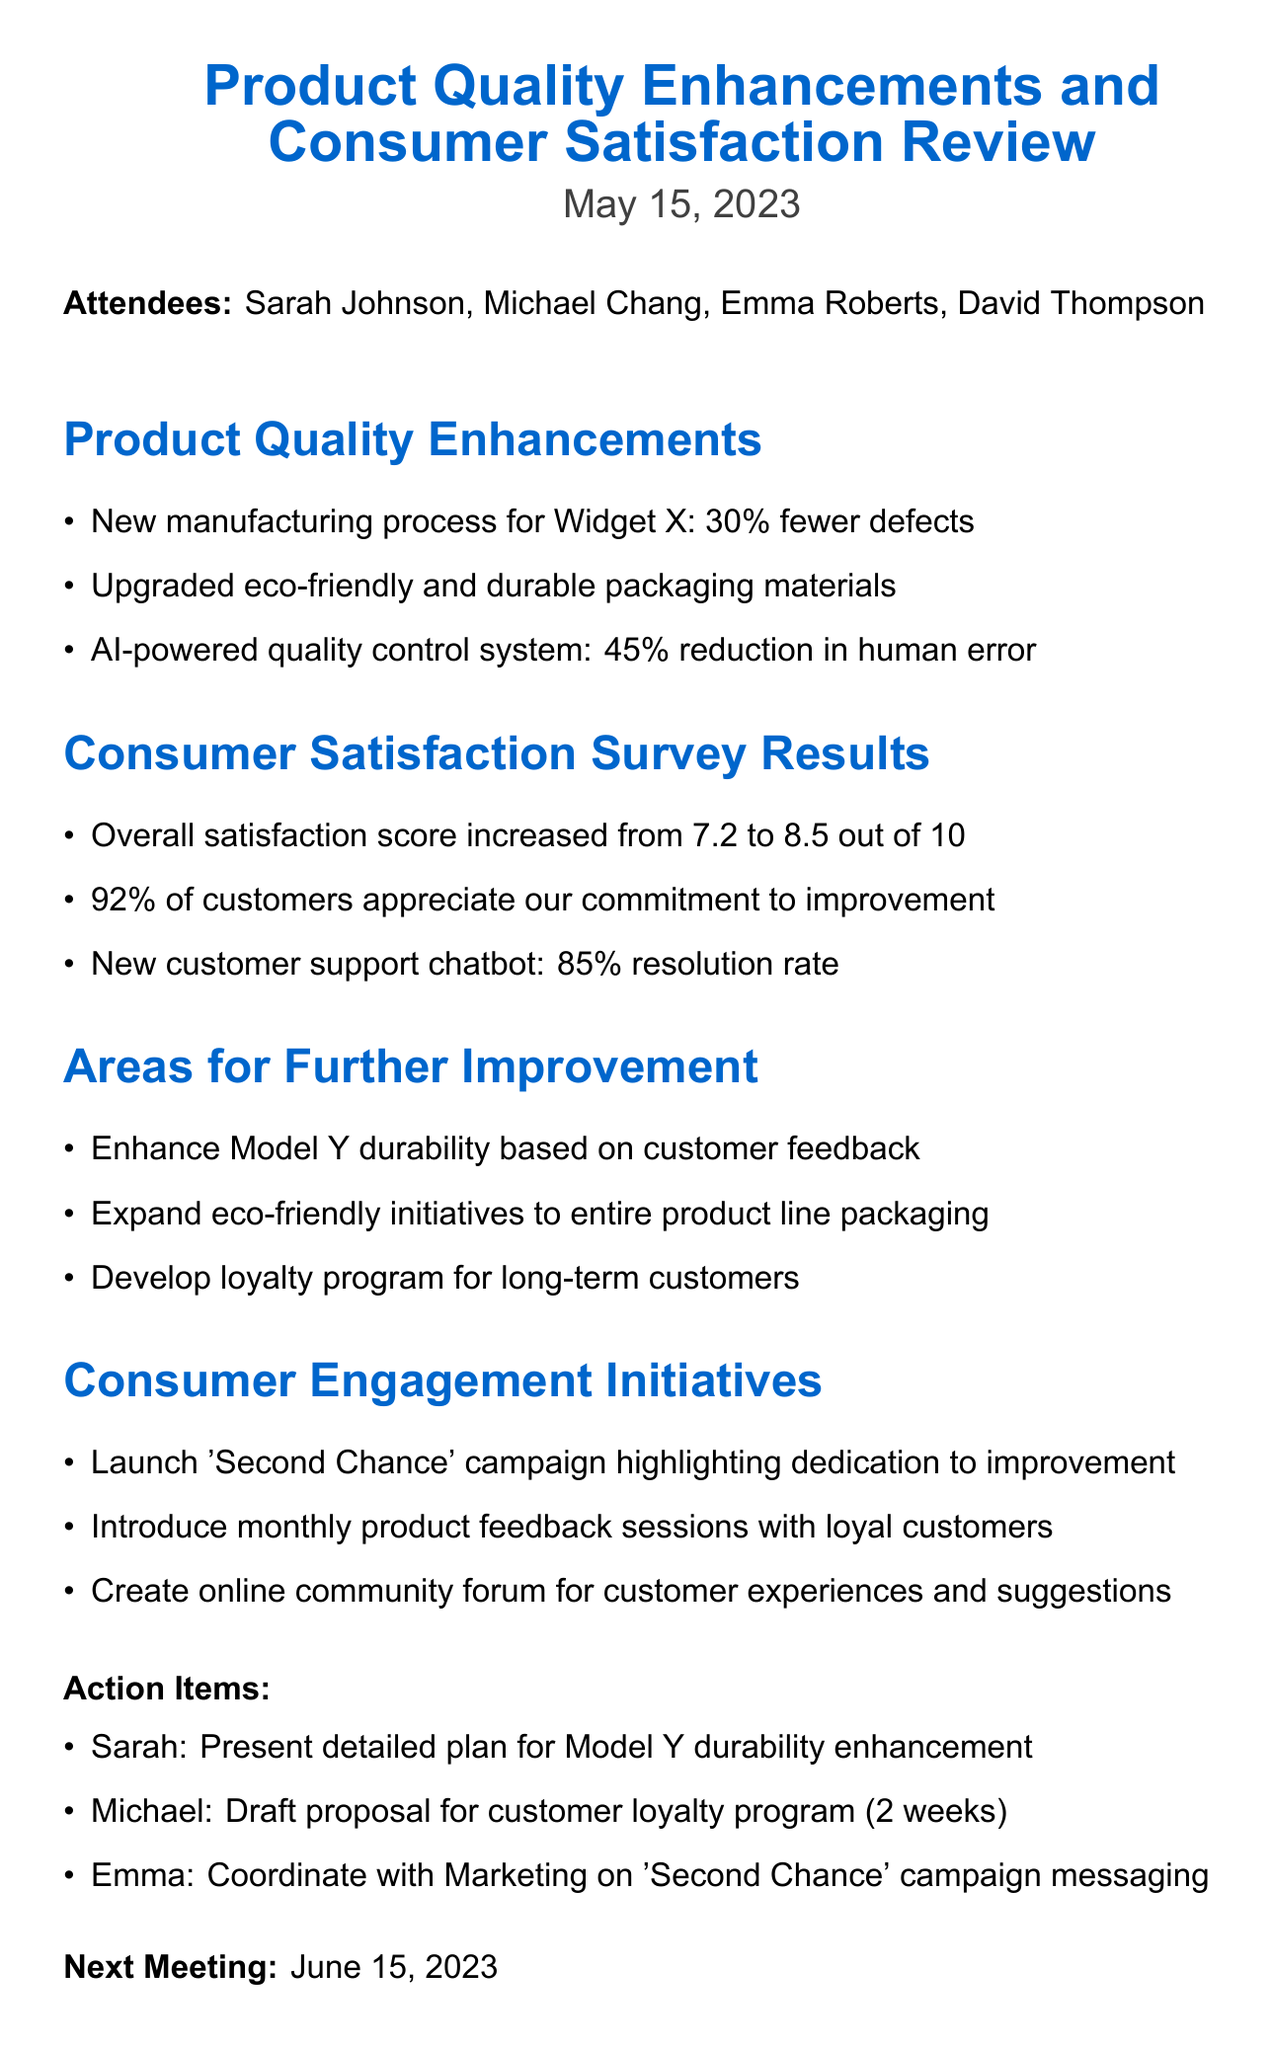What is the date of the meeting? The meeting was held on May 15, 2023.
Answer: May 15, 2023 Who is the Head of Product Development? The document lists Sarah Johnson as the Head of Product Development.
Answer: Sarah Johnson What percentage did the overall satisfaction score increase to? The overall satisfaction score increased from 7.2 to 8.5.
Answer: 8.5 What is one area for further improvement mentioned? The document lists enhancing the product durability of Model Y based on customer feedback as an area for improvement.
Answer: Enhance Model Y durability What is the resolution rate of the new customer support chatbot? The resolution rate of the new customer support chatbot is reported as 85%.
Answer: 85% What initiative highlights the company's dedication to improvement? The document mentions the launch of the 'Second Chance' campaign as an initiative.
Answer: 'Second Chance' campaign How many attendees were present in the meeting? The meeting minutes list four attendees who were present at the meeting.
Answer: Four What action item is Michael responsible for? According to the action items, Michael is to draft a proposal for the customer loyalty program.
Answer: Draft proposal for customer loyalty program 